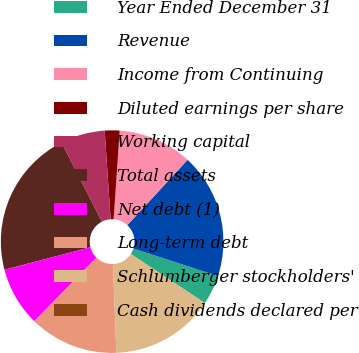Convert chart. <chart><loc_0><loc_0><loc_500><loc_500><pie_chart><fcel>Year Ended December 31<fcel>Revenue<fcel>Income from Continuing<fcel>Diluted earnings per share<fcel>Working capital<fcel>Total assets<fcel>Net debt (1)<fcel>Long-term debt<fcel>Schlumberger stockholders'<fcel>Cash dividends declared per<nl><fcel>4.31%<fcel>18.14%<fcel>10.77%<fcel>2.15%<fcel>6.46%<fcel>21.54%<fcel>8.62%<fcel>12.92%<fcel>15.08%<fcel>0.0%<nl></chart> 